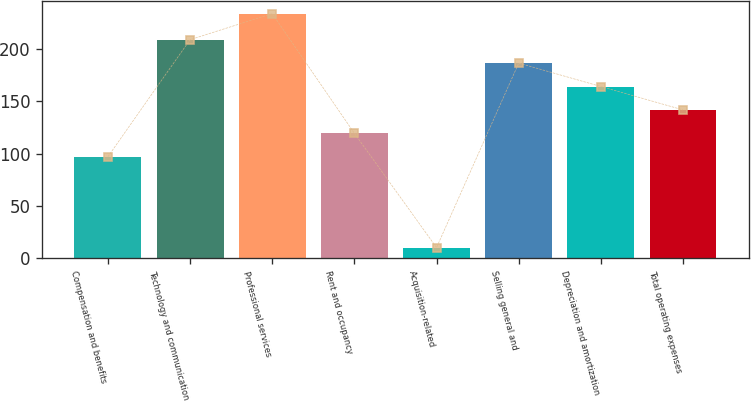<chart> <loc_0><loc_0><loc_500><loc_500><bar_chart><fcel>Compensation and benefits<fcel>Technology and communication<fcel>Professional services<fcel>Rent and occupancy<fcel>Acquisition-related<fcel>Selling general and<fcel>Depreciation and amortization<fcel>Total operating expenses<nl><fcel>97<fcel>209<fcel>234<fcel>119.4<fcel>10<fcel>186.6<fcel>164.2<fcel>141.8<nl></chart> 